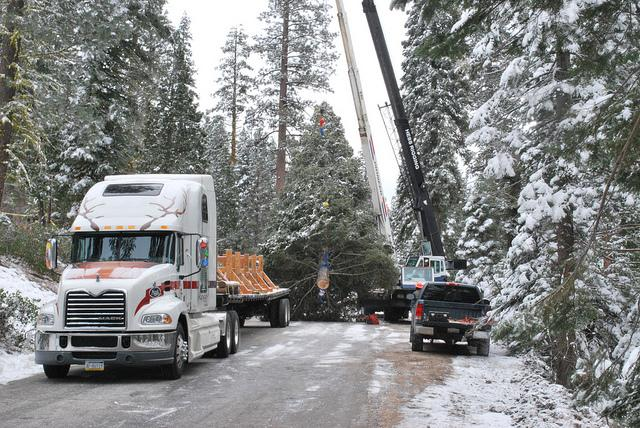What event is taking place here? Please explain your reasoning. logging. The people are cutting down the tree. 